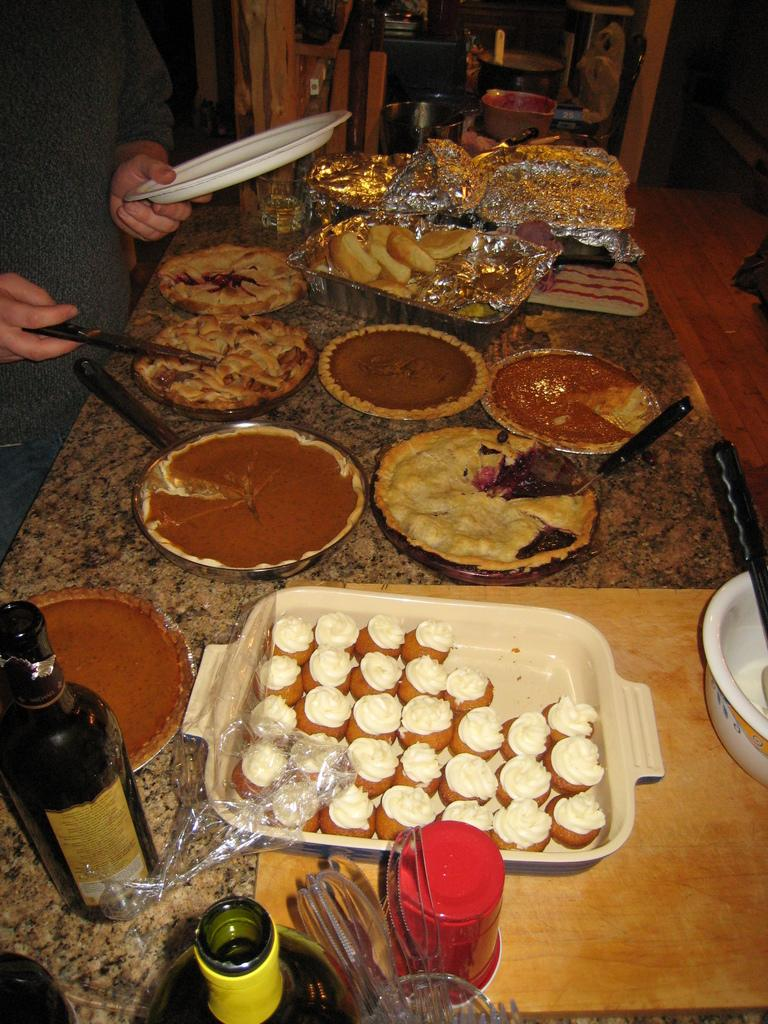What can be seen in the image? There is a person in the image. What is the person holding in their left hand? The person is holding a plate in their left hand. What is the person doing in the image? The person is looking for food. What is located on the left side of the image? There is a wine bottle on the left side of the image. What is in the center of the image? There is a bun in the center of the image. Where is the shelf located in the image? There is no shelf present in the image. Can you see any fans in the image? There are no fans visible in the image. 